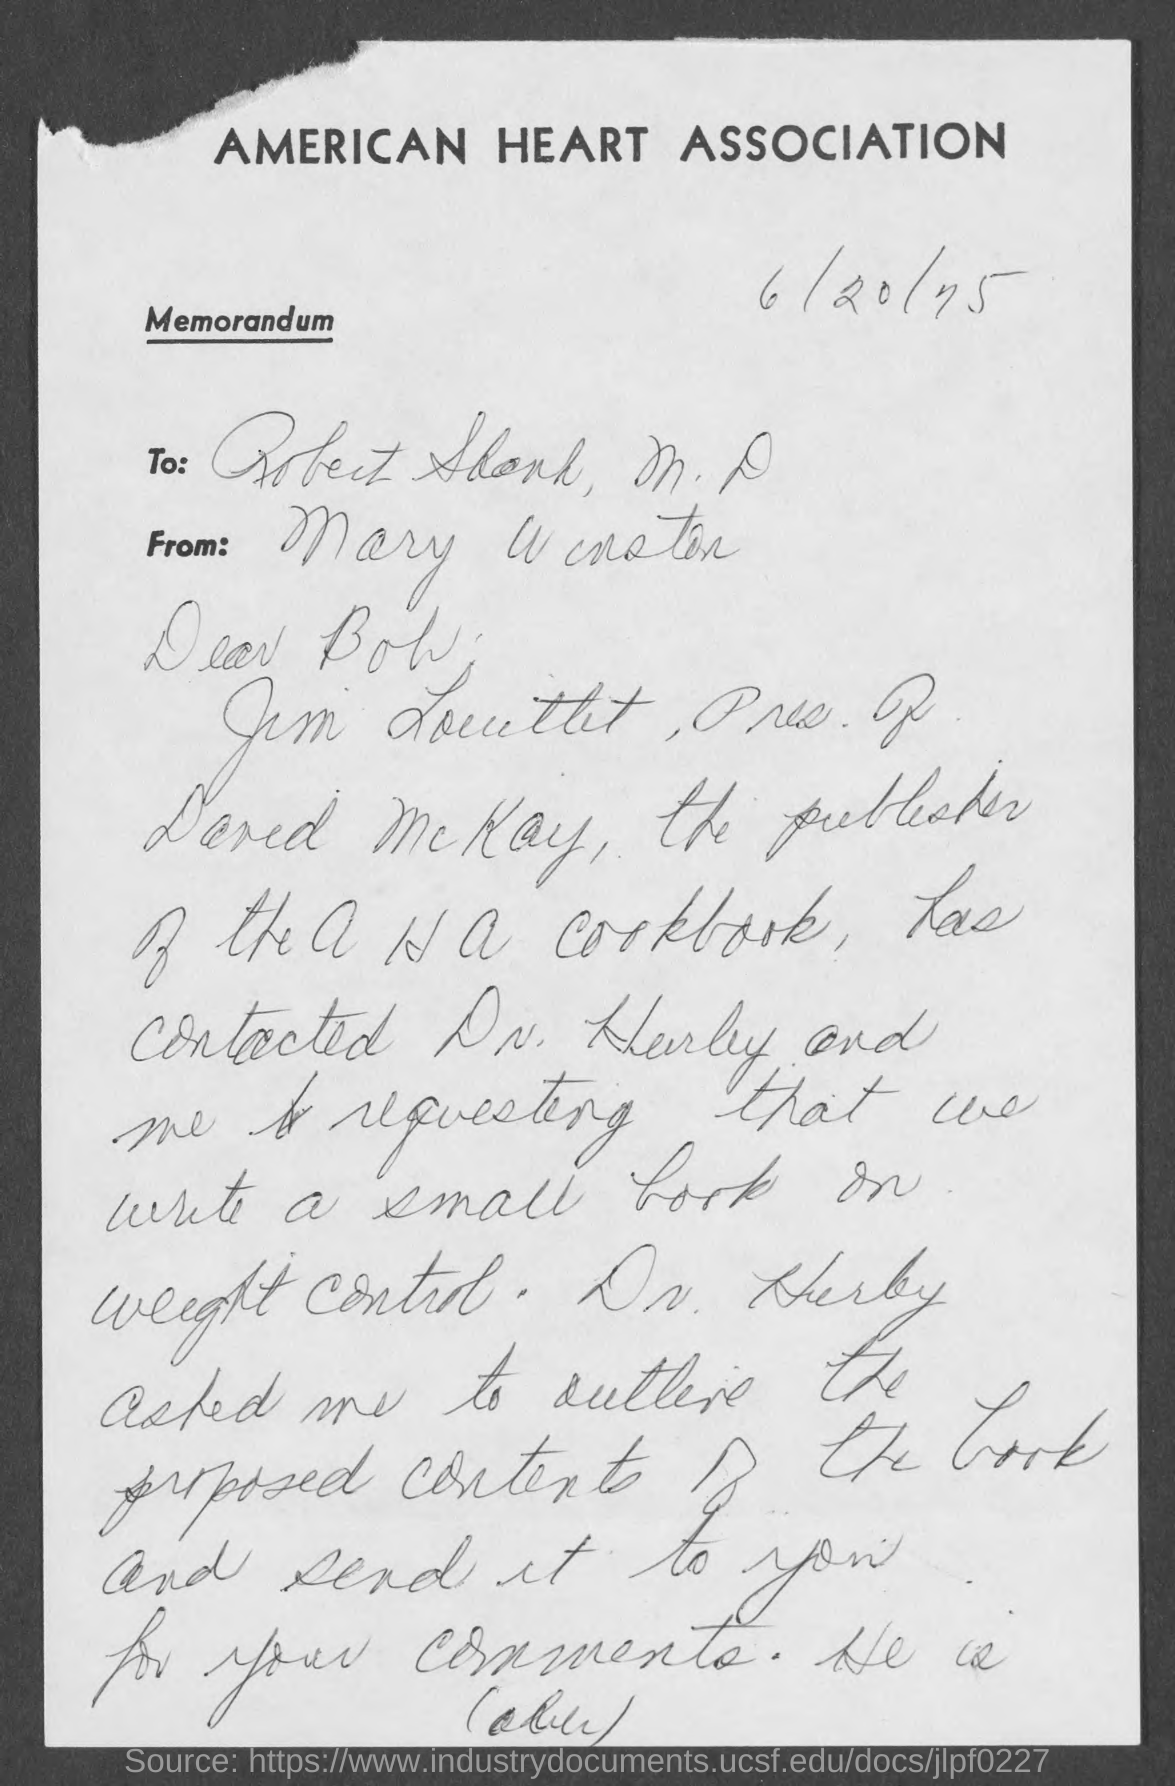Outline some significant characteristics in this image. The American Heart Association is mentioned. 